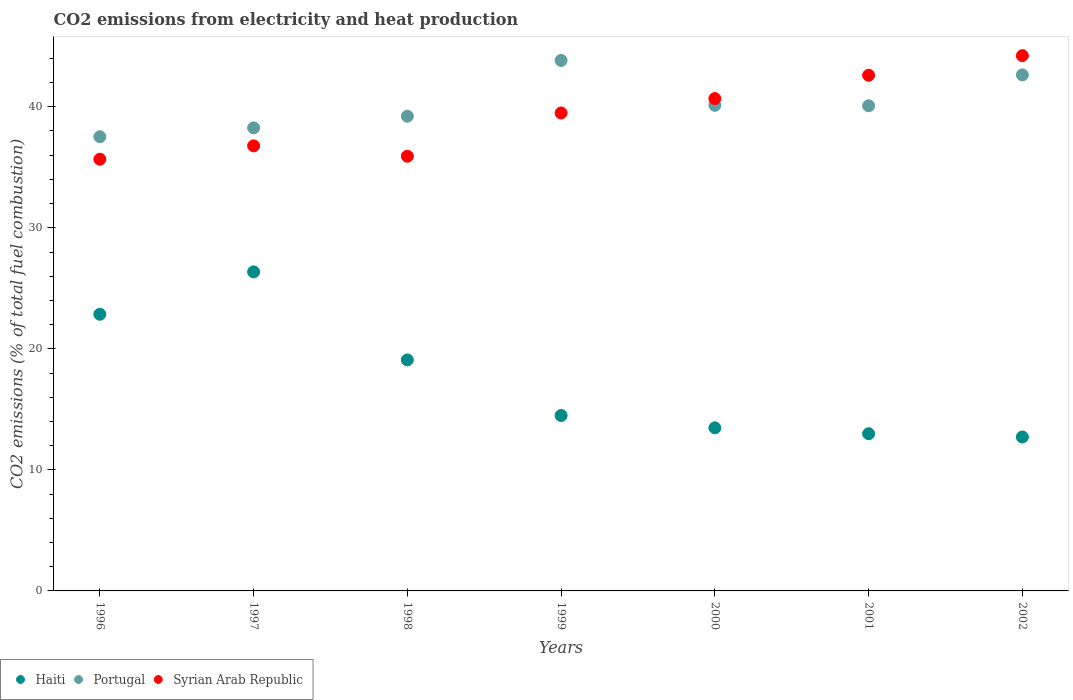How many different coloured dotlines are there?
Your answer should be compact. 3. What is the amount of CO2 emitted in Haiti in 1999?
Offer a terse response. 14.49. Across all years, what is the maximum amount of CO2 emitted in Syrian Arab Republic?
Provide a short and direct response. 44.22. Across all years, what is the minimum amount of CO2 emitted in Haiti?
Provide a short and direct response. 12.72. In which year was the amount of CO2 emitted in Haiti maximum?
Keep it short and to the point. 1997. In which year was the amount of CO2 emitted in Haiti minimum?
Keep it short and to the point. 2002. What is the total amount of CO2 emitted in Haiti in the graph?
Your answer should be compact. 121.97. What is the difference between the amount of CO2 emitted in Portugal in 1997 and that in 2002?
Offer a terse response. -4.38. What is the difference between the amount of CO2 emitted in Haiti in 2002 and the amount of CO2 emitted in Syrian Arab Republic in 1999?
Provide a succinct answer. -26.77. What is the average amount of CO2 emitted in Haiti per year?
Give a very brief answer. 17.42. In the year 2001, what is the difference between the amount of CO2 emitted in Syrian Arab Republic and amount of CO2 emitted in Portugal?
Keep it short and to the point. 2.52. In how many years, is the amount of CO2 emitted in Haiti greater than 22 %?
Ensure brevity in your answer.  2. What is the ratio of the amount of CO2 emitted in Portugal in 1999 to that in 2000?
Keep it short and to the point. 1.09. Is the difference between the amount of CO2 emitted in Syrian Arab Republic in 1998 and 2002 greater than the difference between the amount of CO2 emitted in Portugal in 1998 and 2002?
Give a very brief answer. No. What is the difference between the highest and the second highest amount of CO2 emitted in Syrian Arab Republic?
Your answer should be compact. 1.62. What is the difference between the highest and the lowest amount of CO2 emitted in Portugal?
Offer a very short reply. 6.31. In how many years, is the amount of CO2 emitted in Syrian Arab Republic greater than the average amount of CO2 emitted in Syrian Arab Republic taken over all years?
Your response must be concise. 4. Is the sum of the amount of CO2 emitted in Portugal in 1996 and 2002 greater than the maximum amount of CO2 emitted in Syrian Arab Republic across all years?
Your answer should be very brief. Yes. Is it the case that in every year, the sum of the amount of CO2 emitted in Syrian Arab Republic and amount of CO2 emitted in Portugal  is greater than the amount of CO2 emitted in Haiti?
Your answer should be compact. Yes. Is the amount of CO2 emitted in Syrian Arab Republic strictly less than the amount of CO2 emitted in Haiti over the years?
Your answer should be very brief. No. How many years are there in the graph?
Offer a terse response. 7. Does the graph contain any zero values?
Your answer should be compact. No. Does the graph contain grids?
Provide a succinct answer. No. How many legend labels are there?
Ensure brevity in your answer.  3. How are the legend labels stacked?
Offer a very short reply. Horizontal. What is the title of the graph?
Ensure brevity in your answer.  CO2 emissions from electricity and heat production. Does "Tanzania" appear as one of the legend labels in the graph?
Your response must be concise. No. What is the label or title of the X-axis?
Offer a terse response. Years. What is the label or title of the Y-axis?
Provide a short and direct response. CO2 emissions (% of total fuel combustion). What is the CO2 emissions (% of total fuel combustion) in Haiti in 1996?
Provide a short and direct response. 22.86. What is the CO2 emissions (% of total fuel combustion) in Portugal in 1996?
Provide a succinct answer. 37.52. What is the CO2 emissions (% of total fuel combustion) in Syrian Arab Republic in 1996?
Your answer should be very brief. 35.67. What is the CO2 emissions (% of total fuel combustion) of Haiti in 1997?
Your response must be concise. 26.36. What is the CO2 emissions (% of total fuel combustion) of Portugal in 1997?
Your answer should be compact. 38.26. What is the CO2 emissions (% of total fuel combustion) of Syrian Arab Republic in 1997?
Give a very brief answer. 36.77. What is the CO2 emissions (% of total fuel combustion) of Haiti in 1998?
Offer a terse response. 19.08. What is the CO2 emissions (% of total fuel combustion) in Portugal in 1998?
Your answer should be very brief. 39.22. What is the CO2 emissions (% of total fuel combustion) of Syrian Arab Republic in 1998?
Give a very brief answer. 35.91. What is the CO2 emissions (% of total fuel combustion) in Haiti in 1999?
Offer a terse response. 14.49. What is the CO2 emissions (% of total fuel combustion) of Portugal in 1999?
Give a very brief answer. 43.83. What is the CO2 emissions (% of total fuel combustion) of Syrian Arab Republic in 1999?
Offer a terse response. 39.49. What is the CO2 emissions (% of total fuel combustion) of Haiti in 2000?
Make the answer very short. 13.48. What is the CO2 emissions (% of total fuel combustion) in Portugal in 2000?
Your answer should be compact. 40.12. What is the CO2 emissions (% of total fuel combustion) in Syrian Arab Republic in 2000?
Offer a very short reply. 40.67. What is the CO2 emissions (% of total fuel combustion) in Haiti in 2001?
Make the answer very short. 12.99. What is the CO2 emissions (% of total fuel combustion) of Portugal in 2001?
Provide a succinct answer. 40.08. What is the CO2 emissions (% of total fuel combustion) of Syrian Arab Republic in 2001?
Ensure brevity in your answer.  42.6. What is the CO2 emissions (% of total fuel combustion) of Haiti in 2002?
Provide a succinct answer. 12.72. What is the CO2 emissions (% of total fuel combustion) in Portugal in 2002?
Your answer should be compact. 42.63. What is the CO2 emissions (% of total fuel combustion) in Syrian Arab Republic in 2002?
Provide a short and direct response. 44.22. Across all years, what is the maximum CO2 emissions (% of total fuel combustion) in Haiti?
Keep it short and to the point. 26.36. Across all years, what is the maximum CO2 emissions (% of total fuel combustion) in Portugal?
Your answer should be very brief. 43.83. Across all years, what is the maximum CO2 emissions (% of total fuel combustion) of Syrian Arab Republic?
Your response must be concise. 44.22. Across all years, what is the minimum CO2 emissions (% of total fuel combustion) of Haiti?
Provide a short and direct response. 12.72. Across all years, what is the minimum CO2 emissions (% of total fuel combustion) of Portugal?
Ensure brevity in your answer.  37.52. Across all years, what is the minimum CO2 emissions (% of total fuel combustion) of Syrian Arab Republic?
Make the answer very short. 35.67. What is the total CO2 emissions (% of total fuel combustion) in Haiti in the graph?
Provide a succinct answer. 121.97. What is the total CO2 emissions (% of total fuel combustion) in Portugal in the graph?
Ensure brevity in your answer.  281.66. What is the total CO2 emissions (% of total fuel combustion) in Syrian Arab Republic in the graph?
Ensure brevity in your answer.  275.34. What is the difference between the CO2 emissions (% of total fuel combustion) in Haiti in 1996 and that in 1997?
Offer a very short reply. -3.5. What is the difference between the CO2 emissions (% of total fuel combustion) in Portugal in 1996 and that in 1997?
Offer a terse response. -0.73. What is the difference between the CO2 emissions (% of total fuel combustion) of Syrian Arab Republic in 1996 and that in 1997?
Keep it short and to the point. -1.1. What is the difference between the CO2 emissions (% of total fuel combustion) of Haiti in 1996 and that in 1998?
Your response must be concise. 3.77. What is the difference between the CO2 emissions (% of total fuel combustion) of Portugal in 1996 and that in 1998?
Your answer should be very brief. -1.7. What is the difference between the CO2 emissions (% of total fuel combustion) in Syrian Arab Republic in 1996 and that in 1998?
Your answer should be compact. -0.25. What is the difference between the CO2 emissions (% of total fuel combustion) of Haiti in 1996 and that in 1999?
Your answer should be compact. 8.36. What is the difference between the CO2 emissions (% of total fuel combustion) in Portugal in 1996 and that in 1999?
Your answer should be very brief. -6.31. What is the difference between the CO2 emissions (% of total fuel combustion) of Syrian Arab Republic in 1996 and that in 1999?
Provide a short and direct response. -3.82. What is the difference between the CO2 emissions (% of total fuel combustion) of Haiti in 1996 and that in 2000?
Provide a succinct answer. 9.38. What is the difference between the CO2 emissions (% of total fuel combustion) in Portugal in 1996 and that in 2000?
Your answer should be compact. -2.6. What is the difference between the CO2 emissions (% of total fuel combustion) in Syrian Arab Republic in 1996 and that in 2000?
Provide a short and direct response. -5.01. What is the difference between the CO2 emissions (% of total fuel combustion) in Haiti in 1996 and that in 2001?
Make the answer very short. 9.87. What is the difference between the CO2 emissions (% of total fuel combustion) in Portugal in 1996 and that in 2001?
Ensure brevity in your answer.  -2.56. What is the difference between the CO2 emissions (% of total fuel combustion) of Syrian Arab Republic in 1996 and that in 2001?
Your answer should be compact. -6.94. What is the difference between the CO2 emissions (% of total fuel combustion) in Haiti in 1996 and that in 2002?
Make the answer very short. 10.14. What is the difference between the CO2 emissions (% of total fuel combustion) of Portugal in 1996 and that in 2002?
Offer a very short reply. -5.11. What is the difference between the CO2 emissions (% of total fuel combustion) of Syrian Arab Republic in 1996 and that in 2002?
Offer a terse response. -8.56. What is the difference between the CO2 emissions (% of total fuel combustion) in Haiti in 1997 and that in 1998?
Keep it short and to the point. 7.27. What is the difference between the CO2 emissions (% of total fuel combustion) of Portugal in 1997 and that in 1998?
Ensure brevity in your answer.  -0.96. What is the difference between the CO2 emissions (% of total fuel combustion) in Syrian Arab Republic in 1997 and that in 1998?
Offer a terse response. 0.86. What is the difference between the CO2 emissions (% of total fuel combustion) of Haiti in 1997 and that in 1999?
Provide a succinct answer. 11.86. What is the difference between the CO2 emissions (% of total fuel combustion) of Portugal in 1997 and that in 1999?
Your answer should be compact. -5.57. What is the difference between the CO2 emissions (% of total fuel combustion) in Syrian Arab Republic in 1997 and that in 1999?
Provide a succinct answer. -2.72. What is the difference between the CO2 emissions (% of total fuel combustion) in Haiti in 1997 and that in 2000?
Provide a succinct answer. 12.88. What is the difference between the CO2 emissions (% of total fuel combustion) in Portugal in 1997 and that in 2000?
Give a very brief answer. -1.86. What is the difference between the CO2 emissions (% of total fuel combustion) of Syrian Arab Republic in 1997 and that in 2000?
Your answer should be very brief. -3.9. What is the difference between the CO2 emissions (% of total fuel combustion) of Haiti in 1997 and that in 2001?
Your answer should be compact. 13.37. What is the difference between the CO2 emissions (% of total fuel combustion) in Portugal in 1997 and that in 2001?
Your response must be concise. -1.83. What is the difference between the CO2 emissions (% of total fuel combustion) of Syrian Arab Republic in 1997 and that in 2001?
Your answer should be very brief. -5.83. What is the difference between the CO2 emissions (% of total fuel combustion) of Haiti in 1997 and that in 2002?
Make the answer very short. 13.64. What is the difference between the CO2 emissions (% of total fuel combustion) of Portugal in 1997 and that in 2002?
Offer a terse response. -4.38. What is the difference between the CO2 emissions (% of total fuel combustion) of Syrian Arab Republic in 1997 and that in 2002?
Your response must be concise. -7.45. What is the difference between the CO2 emissions (% of total fuel combustion) of Haiti in 1998 and that in 1999?
Provide a succinct answer. 4.59. What is the difference between the CO2 emissions (% of total fuel combustion) in Portugal in 1998 and that in 1999?
Ensure brevity in your answer.  -4.61. What is the difference between the CO2 emissions (% of total fuel combustion) of Syrian Arab Republic in 1998 and that in 1999?
Keep it short and to the point. -3.58. What is the difference between the CO2 emissions (% of total fuel combustion) in Haiti in 1998 and that in 2000?
Ensure brevity in your answer.  5.61. What is the difference between the CO2 emissions (% of total fuel combustion) of Portugal in 1998 and that in 2000?
Keep it short and to the point. -0.9. What is the difference between the CO2 emissions (% of total fuel combustion) of Syrian Arab Republic in 1998 and that in 2000?
Offer a very short reply. -4.76. What is the difference between the CO2 emissions (% of total fuel combustion) of Haiti in 1998 and that in 2001?
Offer a terse response. 6.1. What is the difference between the CO2 emissions (% of total fuel combustion) in Portugal in 1998 and that in 2001?
Ensure brevity in your answer.  -0.86. What is the difference between the CO2 emissions (% of total fuel combustion) in Syrian Arab Republic in 1998 and that in 2001?
Offer a very short reply. -6.69. What is the difference between the CO2 emissions (% of total fuel combustion) in Haiti in 1998 and that in 2002?
Provide a succinct answer. 6.37. What is the difference between the CO2 emissions (% of total fuel combustion) of Portugal in 1998 and that in 2002?
Ensure brevity in your answer.  -3.41. What is the difference between the CO2 emissions (% of total fuel combustion) of Syrian Arab Republic in 1998 and that in 2002?
Provide a succinct answer. -8.31. What is the difference between the CO2 emissions (% of total fuel combustion) of Haiti in 1999 and that in 2000?
Keep it short and to the point. 1.02. What is the difference between the CO2 emissions (% of total fuel combustion) in Portugal in 1999 and that in 2000?
Give a very brief answer. 3.71. What is the difference between the CO2 emissions (% of total fuel combustion) in Syrian Arab Republic in 1999 and that in 2000?
Provide a succinct answer. -1.18. What is the difference between the CO2 emissions (% of total fuel combustion) in Haiti in 1999 and that in 2001?
Ensure brevity in your answer.  1.51. What is the difference between the CO2 emissions (% of total fuel combustion) of Portugal in 1999 and that in 2001?
Make the answer very short. 3.75. What is the difference between the CO2 emissions (% of total fuel combustion) in Syrian Arab Republic in 1999 and that in 2001?
Ensure brevity in your answer.  -3.11. What is the difference between the CO2 emissions (% of total fuel combustion) in Haiti in 1999 and that in 2002?
Offer a very short reply. 1.78. What is the difference between the CO2 emissions (% of total fuel combustion) in Portugal in 1999 and that in 2002?
Your answer should be very brief. 1.2. What is the difference between the CO2 emissions (% of total fuel combustion) in Syrian Arab Republic in 1999 and that in 2002?
Make the answer very short. -4.73. What is the difference between the CO2 emissions (% of total fuel combustion) in Haiti in 2000 and that in 2001?
Give a very brief answer. 0.49. What is the difference between the CO2 emissions (% of total fuel combustion) in Portugal in 2000 and that in 2001?
Provide a short and direct response. 0.04. What is the difference between the CO2 emissions (% of total fuel combustion) in Syrian Arab Republic in 2000 and that in 2001?
Provide a succinct answer. -1.93. What is the difference between the CO2 emissions (% of total fuel combustion) in Haiti in 2000 and that in 2002?
Your answer should be compact. 0.76. What is the difference between the CO2 emissions (% of total fuel combustion) of Portugal in 2000 and that in 2002?
Your answer should be compact. -2.51. What is the difference between the CO2 emissions (% of total fuel combustion) in Syrian Arab Republic in 2000 and that in 2002?
Make the answer very short. -3.55. What is the difference between the CO2 emissions (% of total fuel combustion) in Haiti in 2001 and that in 2002?
Your response must be concise. 0.27. What is the difference between the CO2 emissions (% of total fuel combustion) of Portugal in 2001 and that in 2002?
Ensure brevity in your answer.  -2.55. What is the difference between the CO2 emissions (% of total fuel combustion) in Syrian Arab Republic in 2001 and that in 2002?
Your answer should be compact. -1.62. What is the difference between the CO2 emissions (% of total fuel combustion) in Haiti in 1996 and the CO2 emissions (% of total fuel combustion) in Portugal in 1997?
Keep it short and to the point. -15.4. What is the difference between the CO2 emissions (% of total fuel combustion) in Haiti in 1996 and the CO2 emissions (% of total fuel combustion) in Syrian Arab Republic in 1997?
Your answer should be compact. -13.91. What is the difference between the CO2 emissions (% of total fuel combustion) in Portugal in 1996 and the CO2 emissions (% of total fuel combustion) in Syrian Arab Republic in 1997?
Offer a very short reply. 0.75. What is the difference between the CO2 emissions (% of total fuel combustion) in Haiti in 1996 and the CO2 emissions (% of total fuel combustion) in Portugal in 1998?
Make the answer very short. -16.36. What is the difference between the CO2 emissions (% of total fuel combustion) in Haiti in 1996 and the CO2 emissions (% of total fuel combustion) in Syrian Arab Republic in 1998?
Your answer should be very brief. -13.05. What is the difference between the CO2 emissions (% of total fuel combustion) of Portugal in 1996 and the CO2 emissions (% of total fuel combustion) of Syrian Arab Republic in 1998?
Your response must be concise. 1.61. What is the difference between the CO2 emissions (% of total fuel combustion) of Haiti in 1996 and the CO2 emissions (% of total fuel combustion) of Portugal in 1999?
Provide a succinct answer. -20.97. What is the difference between the CO2 emissions (% of total fuel combustion) in Haiti in 1996 and the CO2 emissions (% of total fuel combustion) in Syrian Arab Republic in 1999?
Provide a succinct answer. -16.63. What is the difference between the CO2 emissions (% of total fuel combustion) in Portugal in 1996 and the CO2 emissions (% of total fuel combustion) in Syrian Arab Republic in 1999?
Keep it short and to the point. -1.97. What is the difference between the CO2 emissions (% of total fuel combustion) in Haiti in 1996 and the CO2 emissions (% of total fuel combustion) in Portugal in 2000?
Your response must be concise. -17.26. What is the difference between the CO2 emissions (% of total fuel combustion) of Haiti in 1996 and the CO2 emissions (% of total fuel combustion) of Syrian Arab Republic in 2000?
Your answer should be compact. -17.82. What is the difference between the CO2 emissions (% of total fuel combustion) in Portugal in 1996 and the CO2 emissions (% of total fuel combustion) in Syrian Arab Republic in 2000?
Your answer should be very brief. -3.15. What is the difference between the CO2 emissions (% of total fuel combustion) in Haiti in 1996 and the CO2 emissions (% of total fuel combustion) in Portugal in 2001?
Ensure brevity in your answer.  -17.22. What is the difference between the CO2 emissions (% of total fuel combustion) of Haiti in 1996 and the CO2 emissions (% of total fuel combustion) of Syrian Arab Republic in 2001?
Your answer should be very brief. -19.74. What is the difference between the CO2 emissions (% of total fuel combustion) of Portugal in 1996 and the CO2 emissions (% of total fuel combustion) of Syrian Arab Republic in 2001?
Provide a succinct answer. -5.08. What is the difference between the CO2 emissions (% of total fuel combustion) in Haiti in 1996 and the CO2 emissions (% of total fuel combustion) in Portugal in 2002?
Provide a succinct answer. -19.77. What is the difference between the CO2 emissions (% of total fuel combustion) of Haiti in 1996 and the CO2 emissions (% of total fuel combustion) of Syrian Arab Republic in 2002?
Provide a succinct answer. -21.37. What is the difference between the CO2 emissions (% of total fuel combustion) of Portugal in 1996 and the CO2 emissions (% of total fuel combustion) of Syrian Arab Republic in 2002?
Provide a succinct answer. -6.7. What is the difference between the CO2 emissions (% of total fuel combustion) in Haiti in 1997 and the CO2 emissions (% of total fuel combustion) in Portugal in 1998?
Keep it short and to the point. -12.86. What is the difference between the CO2 emissions (% of total fuel combustion) of Haiti in 1997 and the CO2 emissions (% of total fuel combustion) of Syrian Arab Republic in 1998?
Offer a terse response. -9.55. What is the difference between the CO2 emissions (% of total fuel combustion) of Portugal in 1997 and the CO2 emissions (% of total fuel combustion) of Syrian Arab Republic in 1998?
Give a very brief answer. 2.34. What is the difference between the CO2 emissions (% of total fuel combustion) in Haiti in 1997 and the CO2 emissions (% of total fuel combustion) in Portugal in 1999?
Offer a terse response. -17.47. What is the difference between the CO2 emissions (% of total fuel combustion) in Haiti in 1997 and the CO2 emissions (% of total fuel combustion) in Syrian Arab Republic in 1999?
Offer a terse response. -13.13. What is the difference between the CO2 emissions (% of total fuel combustion) of Portugal in 1997 and the CO2 emissions (% of total fuel combustion) of Syrian Arab Republic in 1999?
Provide a short and direct response. -1.23. What is the difference between the CO2 emissions (% of total fuel combustion) of Haiti in 1997 and the CO2 emissions (% of total fuel combustion) of Portugal in 2000?
Offer a very short reply. -13.76. What is the difference between the CO2 emissions (% of total fuel combustion) of Haiti in 1997 and the CO2 emissions (% of total fuel combustion) of Syrian Arab Republic in 2000?
Provide a succinct answer. -14.32. What is the difference between the CO2 emissions (% of total fuel combustion) in Portugal in 1997 and the CO2 emissions (% of total fuel combustion) in Syrian Arab Republic in 2000?
Your response must be concise. -2.42. What is the difference between the CO2 emissions (% of total fuel combustion) in Haiti in 1997 and the CO2 emissions (% of total fuel combustion) in Portugal in 2001?
Your response must be concise. -13.72. What is the difference between the CO2 emissions (% of total fuel combustion) of Haiti in 1997 and the CO2 emissions (% of total fuel combustion) of Syrian Arab Republic in 2001?
Your answer should be very brief. -16.25. What is the difference between the CO2 emissions (% of total fuel combustion) in Portugal in 1997 and the CO2 emissions (% of total fuel combustion) in Syrian Arab Republic in 2001?
Provide a succinct answer. -4.35. What is the difference between the CO2 emissions (% of total fuel combustion) in Haiti in 1997 and the CO2 emissions (% of total fuel combustion) in Portugal in 2002?
Offer a very short reply. -16.28. What is the difference between the CO2 emissions (% of total fuel combustion) of Haiti in 1997 and the CO2 emissions (% of total fuel combustion) of Syrian Arab Republic in 2002?
Your response must be concise. -17.87. What is the difference between the CO2 emissions (% of total fuel combustion) in Portugal in 1997 and the CO2 emissions (% of total fuel combustion) in Syrian Arab Republic in 2002?
Offer a very short reply. -5.97. What is the difference between the CO2 emissions (% of total fuel combustion) of Haiti in 1998 and the CO2 emissions (% of total fuel combustion) of Portugal in 1999?
Make the answer very short. -24.74. What is the difference between the CO2 emissions (% of total fuel combustion) of Haiti in 1998 and the CO2 emissions (% of total fuel combustion) of Syrian Arab Republic in 1999?
Your answer should be compact. -20.41. What is the difference between the CO2 emissions (% of total fuel combustion) of Portugal in 1998 and the CO2 emissions (% of total fuel combustion) of Syrian Arab Republic in 1999?
Give a very brief answer. -0.27. What is the difference between the CO2 emissions (% of total fuel combustion) in Haiti in 1998 and the CO2 emissions (% of total fuel combustion) in Portugal in 2000?
Offer a terse response. -21.03. What is the difference between the CO2 emissions (% of total fuel combustion) of Haiti in 1998 and the CO2 emissions (% of total fuel combustion) of Syrian Arab Republic in 2000?
Keep it short and to the point. -21.59. What is the difference between the CO2 emissions (% of total fuel combustion) in Portugal in 1998 and the CO2 emissions (% of total fuel combustion) in Syrian Arab Republic in 2000?
Ensure brevity in your answer.  -1.46. What is the difference between the CO2 emissions (% of total fuel combustion) of Haiti in 1998 and the CO2 emissions (% of total fuel combustion) of Portugal in 2001?
Your response must be concise. -21. What is the difference between the CO2 emissions (% of total fuel combustion) of Haiti in 1998 and the CO2 emissions (% of total fuel combustion) of Syrian Arab Republic in 2001?
Give a very brief answer. -23.52. What is the difference between the CO2 emissions (% of total fuel combustion) in Portugal in 1998 and the CO2 emissions (% of total fuel combustion) in Syrian Arab Republic in 2001?
Offer a very short reply. -3.38. What is the difference between the CO2 emissions (% of total fuel combustion) of Haiti in 1998 and the CO2 emissions (% of total fuel combustion) of Portugal in 2002?
Provide a short and direct response. -23.55. What is the difference between the CO2 emissions (% of total fuel combustion) in Haiti in 1998 and the CO2 emissions (% of total fuel combustion) in Syrian Arab Republic in 2002?
Offer a terse response. -25.14. What is the difference between the CO2 emissions (% of total fuel combustion) of Portugal in 1998 and the CO2 emissions (% of total fuel combustion) of Syrian Arab Republic in 2002?
Offer a terse response. -5. What is the difference between the CO2 emissions (% of total fuel combustion) in Haiti in 1999 and the CO2 emissions (% of total fuel combustion) in Portugal in 2000?
Make the answer very short. -25.63. What is the difference between the CO2 emissions (% of total fuel combustion) in Haiti in 1999 and the CO2 emissions (% of total fuel combustion) in Syrian Arab Republic in 2000?
Your answer should be very brief. -26.18. What is the difference between the CO2 emissions (% of total fuel combustion) of Portugal in 1999 and the CO2 emissions (% of total fuel combustion) of Syrian Arab Republic in 2000?
Offer a terse response. 3.15. What is the difference between the CO2 emissions (% of total fuel combustion) in Haiti in 1999 and the CO2 emissions (% of total fuel combustion) in Portugal in 2001?
Ensure brevity in your answer.  -25.59. What is the difference between the CO2 emissions (% of total fuel combustion) of Haiti in 1999 and the CO2 emissions (% of total fuel combustion) of Syrian Arab Republic in 2001?
Your answer should be very brief. -28.11. What is the difference between the CO2 emissions (% of total fuel combustion) of Portugal in 1999 and the CO2 emissions (% of total fuel combustion) of Syrian Arab Republic in 2001?
Provide a succinct answer. 1.23. What is the difference between the CO2 emissions (% of total fuel combustion) of Haiti in 1999 and the CO2 emissions (% of total fuel combustion) of Portugal in 2002?
Provide a short and direct response. -28.14. What is the difference between the CO2 emissions (% of total fuel combustion) in Haiti in 1999 and the CO2 emissions (% of total fuel combustion) in Syrian Arab Republic in 2002?
Give a very brief answer. -29.73. What is the difference between the CO2 emissions (% of total fuel combustion) in Portugal in 1999 and the CO2 emissions (% of total fuel combustion) in Syrian Arab Republic in 2002?
Your answer should be very brief. -0.4. What is the difference between the CO2 emissions (% of total fuel combustion) in Haiti in 2000 and the CO2 emissions (% of total fuel combustion) in Portugal in 2001?
Your answer should be very brief. -26.61. What is the difference between the CO2 emissions (% of total fuel combustion) in Haiti in 2000 and the CO2 emissions (% of total fuel combustion) in Syrian Arab Republic in 2001?
Your answer should be very brief. -29.13. What is the difference between the CO2 emissions (% of total fuel combustion) in Portugal in 2000 and the CO2 emissions (% of total fuel combustion) in Syrian Arab Republic in 2001?
Give a very brief answer. -2.48. What is the difference between the CO2 emissions (% of total fuel combustion) in Haiti in 2000 and the CO2 emissions (% of total fuel combustion) in Portugal in 2002?
Offer a very short reply. -29.16. What is the difference between the CO2 emissions (% of total fuel combustion) of Haiti in 2000 and the CO2 emissions (% of total fuel combustion) of Syrian Arab Republic in 2002?
Keep it short and to the point. -30.75. What is the difference between the CO2 emissions (% of total fuel combustion) in Portugal in 2000 and the CO2 emissions (% of total fuel combustion) in Syrian Arab Republic in 2002?
Your answer should be very brief. -4.11. What is the difference between the CO2 emissions (% of total fuel combustion) of Haiti in 2001 and the CO2 emissions (% of total fuel combustion) of Portugal in 2002?
Your answer should be very brief. -29.64. What is the difference between the CO2 emissions (% of total fuel combustion) of Haiti in 2001 and the CO2 emissions (% of total fuel combustion) of Syrian Arab Republic in 2002?
Make the answer very short. -31.24. What is the difference between the CO2 emissions (% of total fuel combustion) of Portugal in 2001 and the CO2 emissions (% of total fuel combustion) of Syrian Arab Republic in 2002?
Offer a very short reply. -4.14. What is the average CO2 emissions (% of total fuel combustion) in Haiti per year?
Your answer should be very brief. 17.42. What is the average CO2 emissions (% of total fuel combustion) of Portugal per year?
Provide a succinct answer. 40.24. What is the average CO2 emissions (% of total fuel combustion) of Syrian Arab Republic per year?
Offer a terse response. 39.33. In the year 1996, what is the difference between the CO2 emissions (% of total fuel combustion) in Haiti and CO2 emissions (% of total fuel combustion) in Portugal?
Ensure brevity in your answer.  -14.66. In the year 1996, what is the difference between the CO2 emissions (% of total fuel combustion) of Haiti and CO2 emissions (% of total fuel combustion) of Syrian Arab Republic?
Provide a short and direct response. -12.81. In the year 1996, what is the difference between the CO2 emissions (% of total fuel combustion) of Portugal and CO2 emissions (% of total fuel combustion) of Syrian Arab Republic?
Make the answer very short. 1.86. In the year 1997, what is the difference between the CO2 emissions (% of total fuel combustion) in Haiti and CO2 emissions (% of total fuel combustion) in Portugal?
Offer a very short reply. -11.9. In the year 1997, what is the difference between the CO2 emissions (% of total fuel combustion) of Haiti and CO2 emissions (% of total fuel combustion) of Syrian Arab Republic?
Make the answer very short. -10.41. In the year 1997, what is the difference between the CO2 emissions (% of total fuel combustion) in Portugal and CO2 emissions (% of total fuel combustion) in Syrian Arab Republic?
Offer a terse response. 1.49. In the year 1998, what is the difference between the CO2 emissions (% of total fuel combustion) of Haiti and CO2 emissions (% of total fuel combustion) of Portugal?
Provide a short and direct response. -20.13. In the year 1998, what is the difference between the CO2 emissions (% of total fuel combustion) of Haiti and CO2 emissions (% of total fuel combustion) of Syrian Arab Republic?
Give a very brief answer. -16.83. In the year 1998, what is the difference between the CO2 emissions (% of total fuel combustion) of Portugal and CO2 emissions (% of total fuel combustion) of Syrian Arab Republic?
Offer a very short reply. 3.31. In the year 1999, what is the difference between the CO2 emissions (% of total fuel combustion) in Haiti and CO2 emissions (% of total fuel combustion) in Portugal?
Offer a terse response. -29.34. In the year 1999, what is the difference between the CO2 emissions (% of total fuel combustion) of Haiti and CO2 emissions (% of total fuel combustion) of Syrian Arab Republic?
Keep it short and to the point. -25. In the year 1999, what is the difference between the CO2 emissions (% of total fuel combustion) in Portugal and CO2 emissions (% of total fuel combustion) in Syrian Arab Republic?
Make the answer very short. 4.34. In the year 2000, what is the difference between the CO2 emissions (% of total fuel combustion) in Haiti and CO2 emissions (% of total fuel combustion) in Portugal?
Give a very brief answer. -26.64. In the year 2000, what is the difference between the CO2 emissions (% of total fuel combustion) in Haiti and CO2 emissions (% of total fuel combustion) in Syrian Arab Republic?
Keep it short and to the point. -27.2. In the year 2000, what is the difference between the CO2 emissions (% of total fuel combustion) of Portugal and CO2 emissions (% of total fuel combustion) of Syrian Arab Republic?
Your answer should be very brief. -0.56. In the year 2001, what is the difference between the CO2 emissions (% of total fuel combustion) of Haiti and CO2 emissions (% of total fuel combustion) of Portugal?
Keep it short and to the point. -27.09. In the year 2001, what is the difference between the CO2 emissions (% of total fuel combustion) in Haiti and CO2 emissions (% of total fuel combustion) in Syrian Arab Republic?
Your response must be concise. -29.61. In the year 2001, what is the difference between the CO2 emissions (% of total fuel combustion) of Portugal and CO2 emissions (% of total fuel combustion) of Syrian Arab Republic?
Keep it short and to the point. -2.52. In the year 2002, what is the difference between the CO2 emissions (% of total fuel combustion) of Haiti and CO2 emissions (% of total fuel combustion) of Portugal?
Your response must be concise. -29.92. In the year 2002, what is the difference between the CO2 emissions (% of total fuel combustion) of Haiti and CO2 emissions (% of total fuel combustion) of Syrian Arab Republic?
Provide a short and direct response. -31.51. In the year 2002, what is the difference between the CO2 emissions (% of total fuel combustion) in Portugal and CO2 emissions (% of total fuel combustion) in Syrian Arab Republic?
Ensure brevity in your answer.  -1.59. What is the ratio of the CO2 emissions (% of total fuel combustion) in Haiti in 1996 to that in 1997?
Your answer should be very brief. 0.87. What is the ratio of the CO2 emissions (% of total fuel combustion) in Portugal in 1996 to that in 1997?
Offer a very short reply. 0.98. What is the ratio of the CO2 emissions (% of total fuel combustion) in Syrian Arab Republic in 1996 to that in 1997?
Your answer should be very brief. 0.97. What is the ratio of the CO2 emissions (% of total fuel combustion) in Haiti in 1996 to that in 1998?
Your answer should be compact. 1.2. What is the ratio of the CO2 emissions (% of total fuel combustion) in Portugal in 1996 to that in 1998?
Provide a succinct answer. 0.96. What is the ratio of the CO2 emissions (% of total fuel combustion) in Syrian Arab Republic in 1996 to that in 1998?
Your response must be concise. 0.99. What is the ratio of the CO2 emissions (% of total fuel combustion) of Haiti in 1996 to that in 1999?
Offer a terse response. 1.58. What is the ratio of the CO2 emissions (% of total fuel combustion) of Portugal in 1996 to that in 1999?
Keep it short and to the point. 0.86. What is the ratio of the CO2 emissions (% of total fuel combustion) in Syrian Arab Republic in 1996 to that in 1999?
Keep it short and to the point. 0.9. What is the ratio of the CO2 emissions (% of total fuel combustion) in Haiti in 1996 to that in 2000?
Offer a terse response. 1.7. What is the ratio of the CO2 emissions (% of total fuel combustion) of Portugal in 1996 to that in 2000?
Make the answer very short. 0.94. What is the ratio of the CO2 emissions (% of total fuel combustion) in Syrian Arab Republic in 1996 to that in 2000?
Give a very brief answer. 0.88. What is the ratio of the CO2 emissions (% of total fuel combustion) in Haiti in 1996 to that in 2001?
Ensure brevity in your answer.  1.76. What is the ratio of the CO2 emissions (% of total fuel combustion) of Portugal in 1996 to that in 2001?
Your answer should be very brief. 0.94. What is the ratio of the CO2 emissions (% of total fuel combustion) in Syrian Arab Republic in 1996 to that in 2001?
Your answer should be compact. 0.84. What is the ratio of the CO2 emissions (% of total fuel combustion) of Haiti in 1996 to that in 2002?
Provide a short and direct response. 1.8. What is the ratio of the CO2 emissions (% of total fuel combustion) in Portugal in 1996 to that in 2002?
Give a very brief answer. 0.88. What is the ratio of the CO2 emissions (% of total fuel combustion) in Syrian Arab Republic in 1996 to that in 2002?
Your response must be concise. 0.81. What is the ratio of the CO2 emissions (% of total fuel combustion) in Haiti in 1997 to that in 1998?
Keep it short and to the point. 1.38. What is the ratio of the CO2 emissions (% of total fuel combustion) of Portugal in 1997 to that in 1998?
Ensure brevity in your answer.  0.98. What is the ratio of the CO2 emissions (% of total fuel combustion) of Syrian Arab Republic in 1997 to that in 1998?
Keep it short and to the point. 1.02. What is the ratio of the CO2 emissions (% of total fuel combustion) in Haiti in 1997 to that in 1999?
Provide a succinct answer. 1.82. What is the ratio of the CO2 emissions (% of total fuel combustion) in Portugal in 1997 to that in 1999?
Your answer should be compact. 0.87. What is the ratio of the CO2 emissions (% of total fuel combustion) of Syrian Arab Republic in 1997 to that in 1999?
Offer a very short reply. 0.93. What is the ratio of the CO2 emissions (% of total fuel combustion) of Haiti in 1997 to that in 2000?
Provide a short and direct response. 1.96. What is the ratio of the CO2 emissions (% of total fuel combustion) of Portugal in 1997 to that in 2000?
Provide a succinct answer. 0.95. What is the ratio of the CO2 emissions (% of total fuel combustion) in Syrian Arab Republic in 1997 to that in 2000?
Make the answer very short. 0.9. What is the ratio of the CO2 emissions (% of total fuel combustion) of Haiti in 1997 to that in 2001?
Your response must be concise. 2.03. What is the ratio of the CO2 emissions (% of total fuel combustion) of Portugal in 1997 to that in 2001?
Give a very brief answer. 0.95. What is the ratio of the CO2 emissions (% of total fuel combustion) in Syrian Arab Republic in 1997 to that in 2001?
Give a very brief answer. 0.86. What is the ratio of the CO2 emissions (% of total fuel combustion) of Haiti in 1997 to that in 2002?
Provide a short and direct response. 2.07. What is the ratio of the CO2 emissions (% of total fuel combustion) of Portugal in 1997 to that in 2002?
Your answer should be very brief. 0.9. What is the ratio of the CO2 emissions (% of total fuel combustion) in Syrian Arab Republic in 1997 to that in 2002?
Provide a succinct answer. 0.83. What is the ratio of the CO2 emissions (% of total fuel combustion) in Haiti in 1998 to that in 1999?
Offer a terse response. 1.32. What is the ratio of the CO2 emissions (% of total fuel combustion) in Portugal in 1998 to that in 1999?
Offer a very short reply. 0.89. What is the ratio of the CO2 emissions (% of total fuel combustion) in Syrian Arab Republic in 1998 to that in 1999?
Make the answer very short. 0.91. What is the ratio of the CO2 emissions (% of total fuel combustion) in Haiti in 1998 to that in 2000?
Keep it short and to the point. 1.42. What is the ratio of the CO2 emissions (% of total fuel combustion) in Portugal in 1998 to that in 2000?
Provide a succinct answer. 0.98. What is the ratio of the CO2 emissions (% of total fuel combustion) in Syrian Arab Republic in 1998 to that in 2000?
Your answer should be very brief. 0.88. What is the ratio of the CO2 emissions (% of total fuel combustion) of Haiti in 1998 to that in 2001?
Offer a terse response. 1.47. What is the ratio of the CO2 emissions (% of total fuel combustion) in Portugal in 1998 to that in 2001?
Ensure brevity in your answer.  0.98. What is the ratio of the CO2 emissions (% of total fuel combustion) in Syrian Arab Republic in 1998 to that in 2001?
Keep it short and to the point. 0.84. What is the ratio of the CO2 emissions (% of total fuel combustion) in Haiti in 1998 to that in 2002?
Offer a terse response. 1.5. What is the ratio of the CO2 emissions (% of total fuel combustion) in Portugal in 1998 to that in 2002?
Ensure brevity in your answer.  0.92. What is the ratio of the CO2 emissions (% of total fuel combustion) of Syrian Arab Republic in 1998 to that in 2002?
Ensure brevity in your answer.  0.81. What is the ratio of the CO2 emissions (% of total fuel combustion) in Haiti in 1999 to that in 2000?
Give a very brief answer. 1.08. What is the ratio of the CO2 emissions (% of total fuel combustion) in Portugal in 1999 to that in 2000?
Offer a terse response. 1.09. What is the ratio of the CO2 emissions (% of total fuel combustion) of Syrian Arab Republic in 1999 to that in 2000?
Your answer should be very brief. 0.97. What is the ratio of the CO2 emissions (% of total fuel combustion) of Haiti in 1999 to that in 2001?
Your response must be concise. 1.12. What is the ratio of the CO2 emissions (% of total fuel combustion) of Portugal in 1999 to that in 2001?
Make the answer very short. 1.09. What is the ratio of the CO2 emissions (% of total fuel combustion) of Syrian Arab Republic in 1999 to that in 2001?
Your answer should be very brief. 0.93. What is the ratio of the CO2 emissions (% of total fuel combustion) in Haiti in 1999 to that in 2002?
Your response must be concise. 1.14. What is the ratio of the CO2 emissions (% of total fuel combustion) in Portugal in 1999 to that in 2002?
Provide a succinct answer. 1.03. What is the ratio of the CO2 emissions (% of total fuel combustion) of Syrian Arab Republic in 1999 to that in 2002?
Offer a very short reply. 0.89. What is the ratio of the CO2 emissions (% of total fuel combustion) of Haiti in 2000 to that in 2001?
Provide a short and direct response. 1.04. What is the ratio of the CO2 emissions (% of total fuel combustion) of Syrian Arab Republic in 2000 to that in 2001?
Give a very brief answer. 0.95. What is the ratio of the CO2 emissions (% of total fuel combustion) in Haiti in 2000 to that in 2002?
Ensure brevity in your answer.  1.06. What is the ratio of the CO2 emissions (% of total fuel combustion) of Portugal in 2000 to that in 2002?
Your answer should be very brief. 0.94. What is the ratio of the CO2 emissions (% of total fuel combustion) of Syrian Arab Republic in 2000 to that in 2002?
Ensure brevity in your answer.  0.92. What is the ratio of the CO2 emissions (% of total fuel combustion) in Haiti in 2001 to that in 2002?
Offer a very short reply. 1.02. What is the ratio of the CO2 emissions (% of total fuel combustion) in Portugal in 2001 to that in 2002?
Make the answer very short. 0.94. What is the ratio of the CO2 emissions (% of total fuel combustion) of Syrian Arab Republic in 2001 to that in 2002?
Make the answer very short. 0.96. What is the difference between the highest and the second highest CO2 emissions (% of total fuel combustion) in Haiti?
Make the answer very short. 3.5. What is the difference between the highest and the second highest CO2 emissions (% of total fuel combustion) in Portugal?
Provide a succinct answer. 1.2. What is the difference between the highest and the second highest CO2 emissions (% of total fuel combustion) of Syrian Arab Republic?
Your answer should be very brief. 1.62. What is the difference between the highest and the lowest CO2 emissions (% of total fuel combustion) of Haiti?
Your answer should be compact. 13.64. What is the difference between the highest and the lowest CO2 emissions (% of total fuel combustion) in Portugal?
Offer a terse response. 6.31. What is the difference between the highest and the lowest CO2 emissions (% of total fuel combustion) in Syrian Arab Republic?
Give a very brief answer. 8.56. 